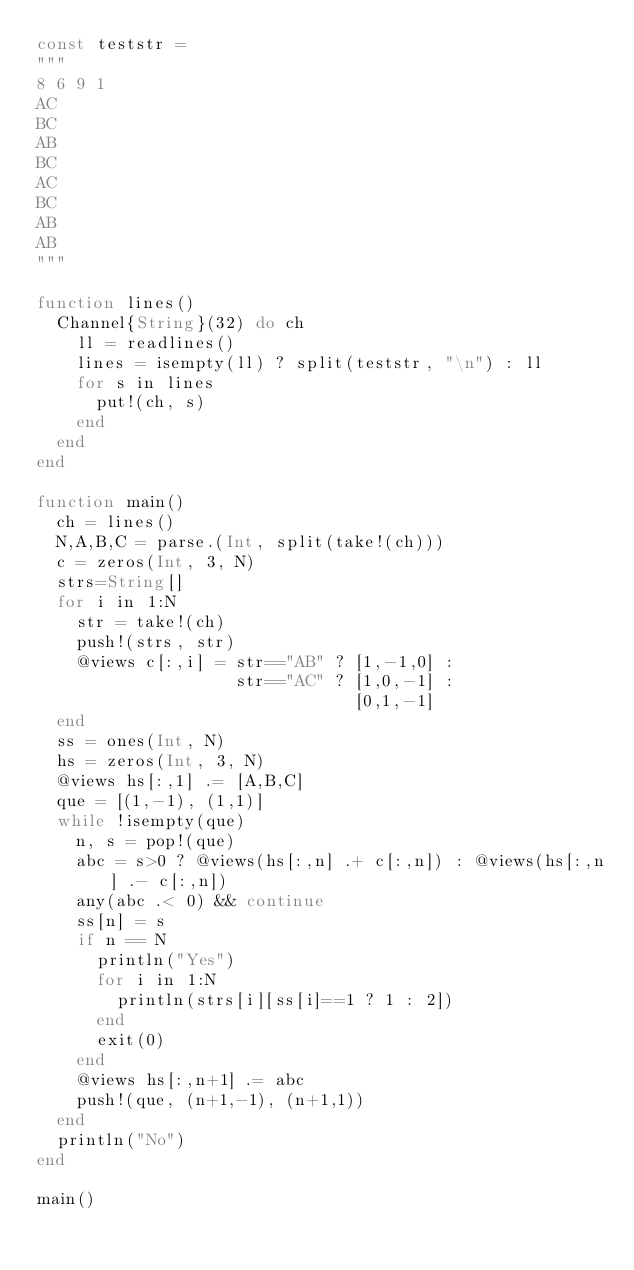Convert code to text. <code><loc_0><loc_0><loc_500><loc_500><_Julia_>const teststr = 
"""
8 6 9 1
AC
BC
AB
BC
AC
BC
AB
AB
"""

function lines()
  Channel{String}(32) do ch
    ll = readlines()
    lines = isempty(ll) ? split(teststr, "\n") : ll
    for s in lines
      put!(ch, s)
    end
  end
end

function main()
  ch = lines()
  N,A,B,C = parse.(Int, split(take!(ch)))
  c = zeros(Int, 3, N)
  strs=String[]
  for i in 1:N
    str = take!(ch)
    push!(strs, str)
    @views c[:,i] = str=="AB" ? [1,-1,0] :
                    str=="AC" ? [1,0,-1] :
                                [0,1,-1]
  end
  ss = ones(Int, N)
  hs = zeros(Int, 3, N)
  @views hs[:,1] .= [A,B,C]
  que = [(1,-1), (1,1)]
  while !isempty(que)
    n, s = pop!(que)
    abc = s>0 ? @views(hs[:,n] .+ c[:,n]) : @views(hs[:,n] .- c[:,n])
    any(abc .< 0) && continue
    ss[n] = s
    if n == N
      println("Yes")
      for i in 1:N
        println(strs[i][ss[i]==1 ? 1 : 2])
      end
      exit(0)
    end
    @views hs[:,n+1] .= abc
	push!(que, (n+1,-1), (n+1,1))
  end
  println("No")
end

main()</code> 